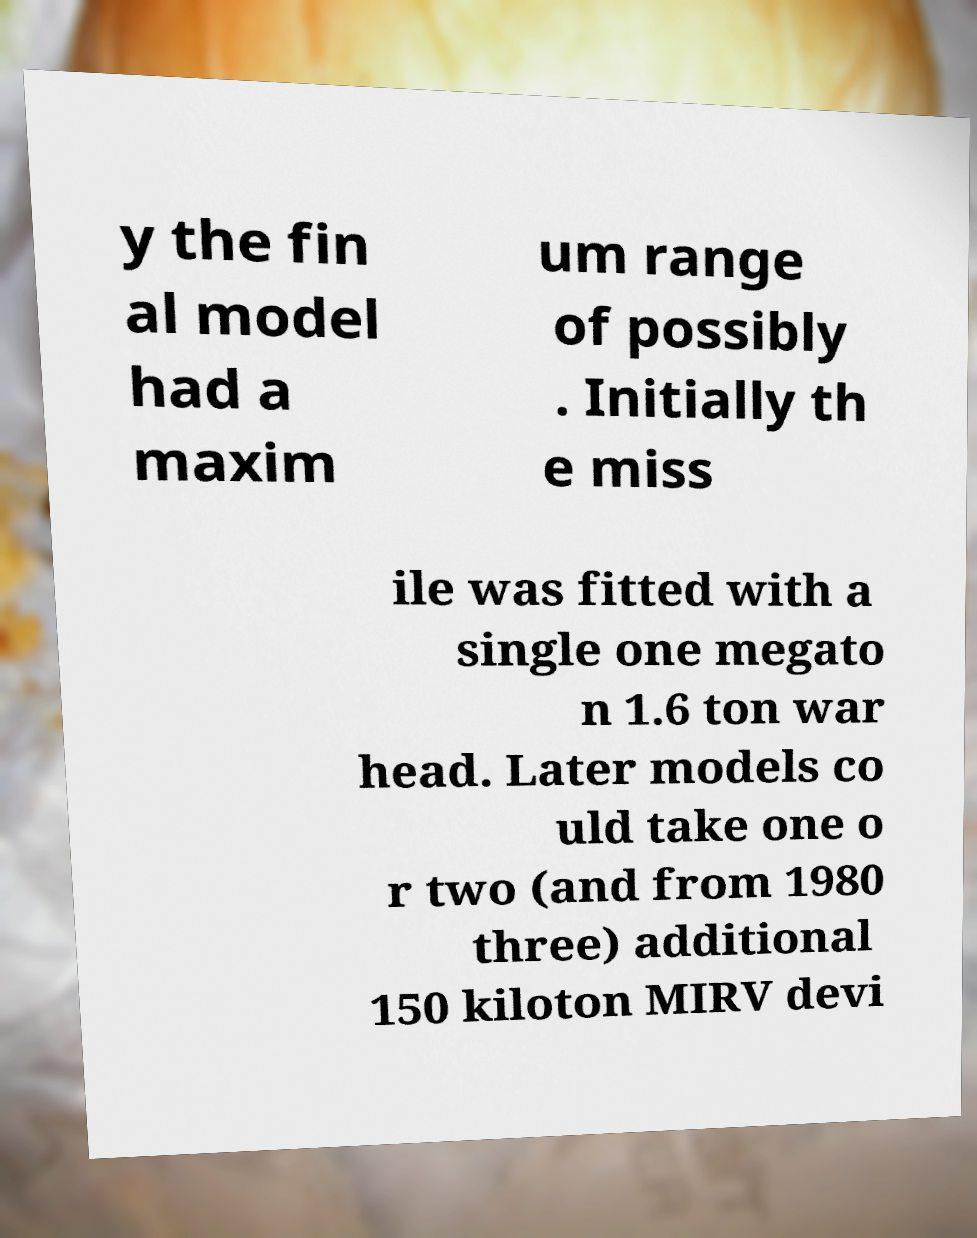There's text embedded in this image that I need extracted. Can you transcribe it verbatim? y the fin al model had a maxim um range of possibly . Initially th e miss ile was fitted with a single one megato n 1.6 ton war head. Later models co uld take one o r two (and from 1980 three) additional 150 kiloton MIRV devi 